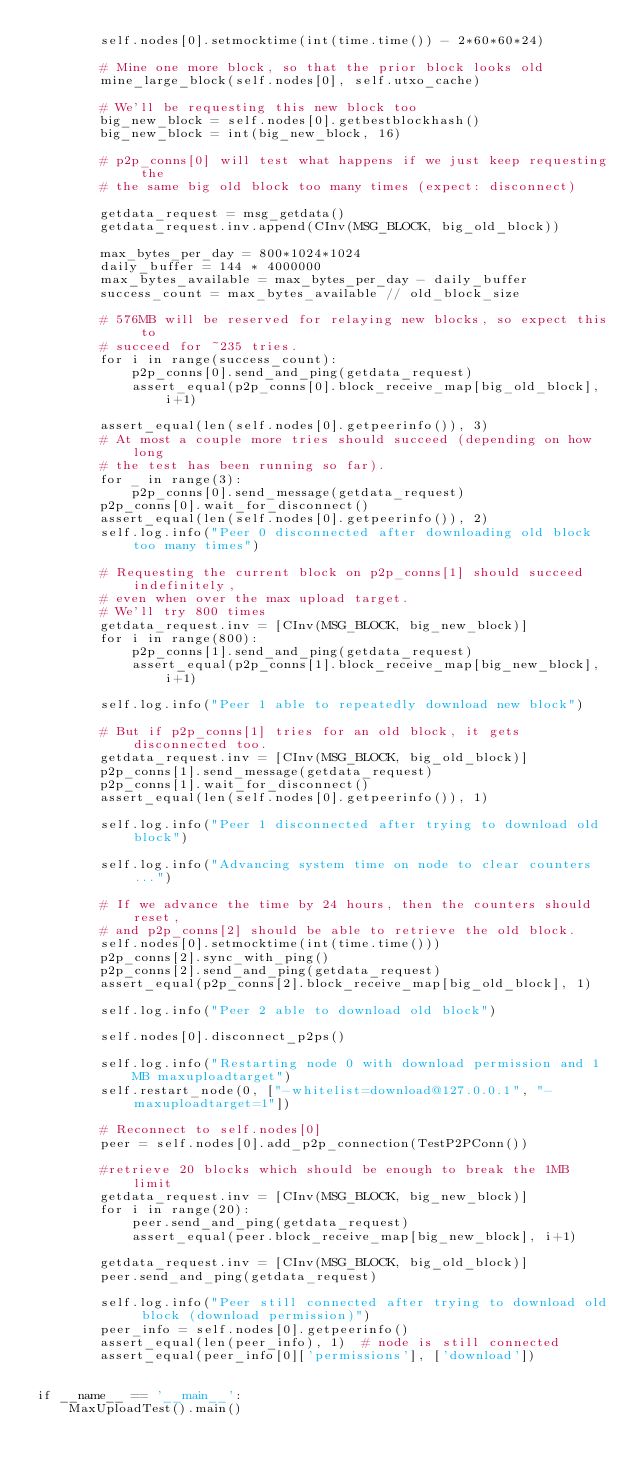Convert code to text. <code><loc_0><loc_0><loc_500><loc_500><_Python_>        self.nodes[0].setmocktime(int(time.time()) - 2*60*60*24)

        # Mine one more block, so that the prior block looks old
        mine_large_block(self.nodes[0], self.utxo_cache)

        # We'll be requesting this new block too
        big_new_block = self.nodes[0].getbestblockhash()
        big_new_block = int(big_new_block, 16)

        # p2p_conns[0] will test what happens if we just keep requesting the
        # the same big old block too many times (expect: disconnect)

        getdata_request = msg_getdata()
        getdata_request.inv.append(CInv(MSG_BLOCK, big_old_block))

        max_bytes_per_day = 800*1024*1024
        daily_buffer = 144 * 4000000
        max_bytes_available = max_bytes_per_day - daily_buffer
        success_count = max_bytes_available // old_block_size

        # 576MB will be reserved for relaying new blocks, so expect this to
        # succeed for ~235 tries.
        for i in range(success_count):
            p2p_conns[0].send_and_ping(getdata_request)
            assert_equal(p2p_conns[0].block_receive_map[big_old_block], i+1)

        assert_equal(len(self.nodes[0].getpeerinfo()), 3)
        # At most a couple more tries should succeed (depending on how long
        # the test has been running so far).
        for _ in range(3):
            p2p_conns[0].send_message(getdata_request)
        p2p_conns[0].wait_for_disconnect()
        assert_equal(len(self.nodes[0].getpeerinfo()), 2)
        self.log.info("Peer 0 disconnected after downloading old block too many times")

        # Requesting the current block on p2p_conns[1] should succeed indefinitely,
        # even when over the max upload target.
        # We'll try 800 times
        getdata_request.inv = [CInv(MSG_BLOCK, big_new_block)]
        for i in range(800):
            p2p_conns[1].send_and_ping(getdata_request)
            assert_equal(p2p_conns[1].block_receive_map[big_new_block], i+1)

        self.log.info("Peer 1 able to repeatedly download new block")

        # But if p2p_conns[1] tries for an old block, it gets disconnected too.
        getdata_request.inv = [CInv(MSG_BLOCK, big_old_block)]
        p2p_conns[1].send_message(getdata_request)
        p2p_conns[1].wait_for_disconnect()
        assert_equal(len(self.nodes[0].getpeerinfo()), 1)

        self.log.info("Peer 1 disconnected after trying to download old block")

        self.log.info("Advancing system time on node to clear counters...")

        # If we advance the time by 24 hours, then the counters should reset,
        # and p2p_conns[2] should be able to retrieve the old block.
        self.nodes[0].setmocktime(int(time.time()))
        p2p_conns[2].sync_with_ping()
        p2p_conns[2].send_and_ping(getdata_request)
        assert_equal(p2p_conns[2].block_receive_map[big_old_block], 1)

        self.log.info("Peer 2 able to download old block")

        self.nodes[0].disconnect_p2ps()

        self.log.info("Restarting node 0 with download permission and 1MB maxuploadtarget")
        self.restart_node(0, ["-whitelist=download@127.0.0.1", "-maxuploadtarget=1"])

        # Reconnect to self.nodes[0]
        peer = self.nodes[0].add_p2p_connection(TestP2PConn())

        #retrieve 20 blocks which should be enough to break the 1MB limit
        getdata_request.inv = [CInv(MSG_BLOCK, big_new_block)]
        for i in range(20):
            peer.send_and_ping(getdata_request)
            assert_equal(peer.block_receive_map[big_new_block], i+1)

        getdata_request.inv = [CInv(MSG_BLOCK, big_old_block)]
        peer.send_and_ping(getdata_request)

        self.log.info("Peer still connected after trying to download old block (download permission)")
        peer_info = self.nodes[0].getpeerinfo()
        assert_equal(len(peer_info), 1)  # node is still connected
        assert_equal(peer_info[0]['permissions'], ['download'])


if __name__ == '__main__':
    MaxUploadTest().main()
</code> 